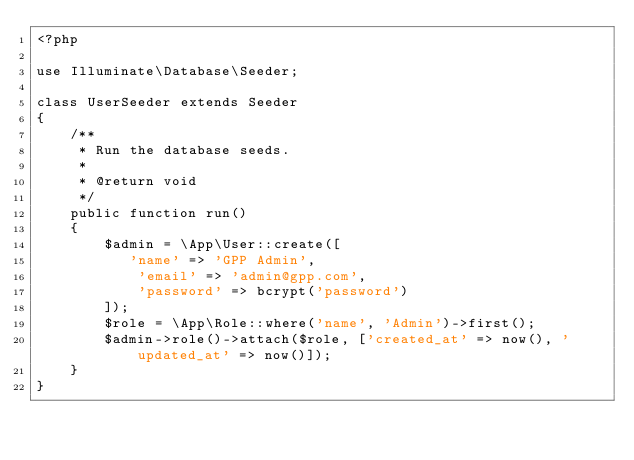Convert code to text. <code><loc_0><loc_0><loc_500><loc_500><_PHP_><?php

use Illuminate\Database\Seeder;

class UserSeeder extends Seeder
{
    /**
     * Run the database seeds.
     *
     * @return void
     */
    public function run()
    {
        $admin = \App\User::create([
           'name' => 'GPP Admin',
            'email' => 'admin@gpp.com',
            'password' => bcrypt('password')
        ]);
        $role = \App\Role::where('name', 'Admin')->first();
        $admin->role()->attach($role, ['created_at' => now(), 'updated_at' => now()]);
    }
}
</code> 